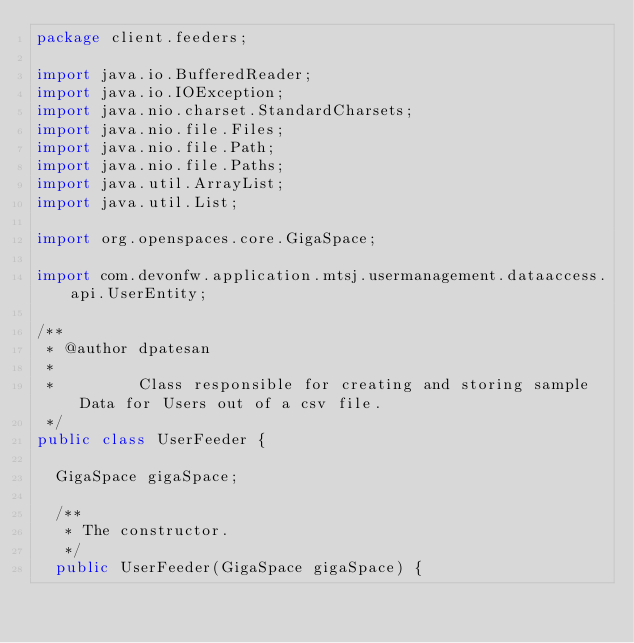Convert code to text. <code><loc_0><loc_0><loc_500><loc_500><_Java_>package client.feeders;

import java.io.BufferedReader;
import java.io.IOException;
import java.nio.charset.StandardCharsets;
import java.nio.file.Files;
import java.nio.file.Path;
import java.nio.file.Paths;
import java.util.ArrayList;
import java.util.List;

import org.openspaces.core.GigaSpace;

import com.devonfw.application.mtsj.usermanagement.dataaccess.api.UserEntity;

/**
 * @author dpatesan
 *
 *         Class responsible for creating and storing sample Data for Users out of a csv file.
 */
public class UserFeeder {

  GigaSpace gigaSpace;

  /**
   * The constructor.
   */
  public UserFeeder(GigaSpace gigaSpace) {
</code> 